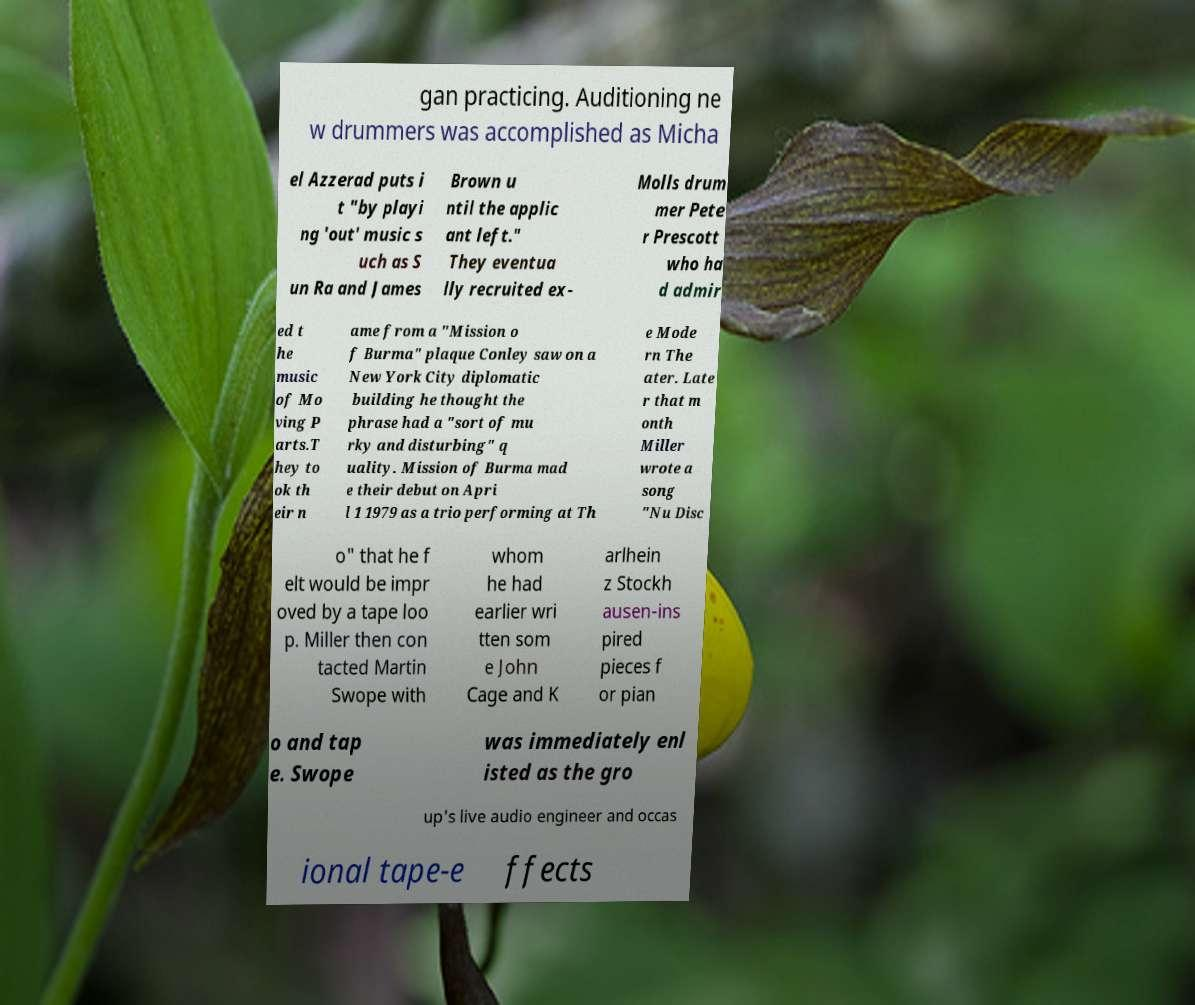Could you extract and type out the text from this image? gan practicing. Auditioning ne w drummers was accomplished as Micha el Azzerad puts i t "by playi ng 'out' music s uch as S un Ra and James Brown u ntil the applic ant left." They eventua lly recruited ex- Molls drum mer Pete r Prescott who ha d admir ed t he music of Mo ving P arts.T hey to ok th eir n ame from a "Mission o f Burma" plaque Conley saw on a New York City diplomatic building he thought the phrase had a "sort of mu rky and disturbing" q uality. Mission of Burma mad e their debut on Apri l 1 1979 as a trio performing at Th e Mode rn The ater. Late r that m onth Miller wrote a song "Nu Disc o" that he f elt would be impr oved by a tape loo p. Miller then con tacted Martin Swope with whom he had earlier wri tten som e John Cage and K arlhein z Stockh ausen-ins pired pieces f or pian o and tap e. Swope was immediately enl isted as the gro up's live audio engineer and occas ional tape-e ffects 